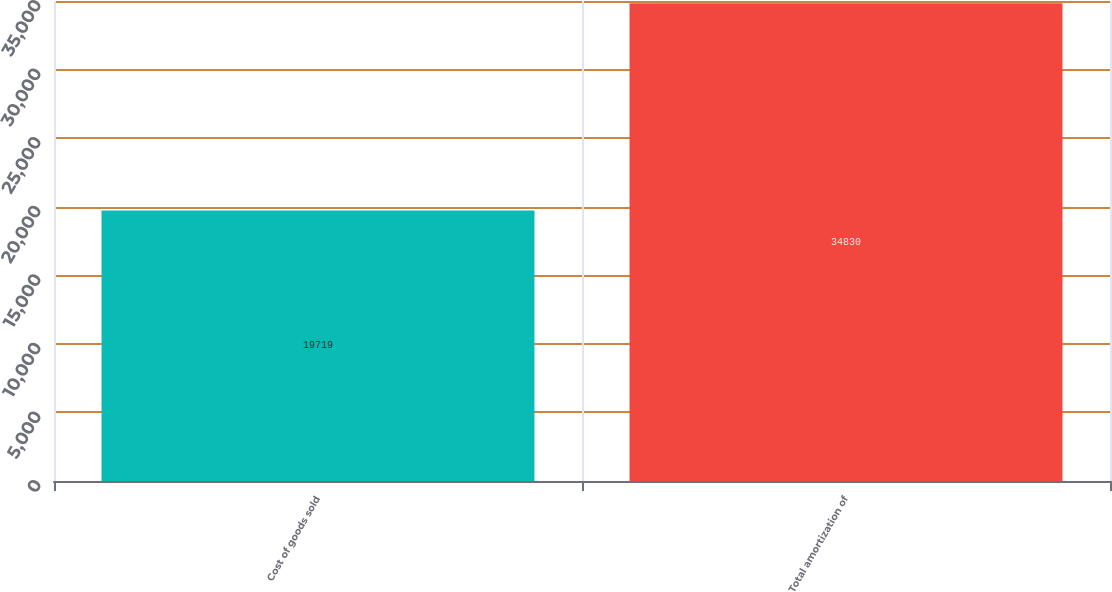<chart> <loc_0><loc_0><loc_500><loc_500><bar_chart><fcel>Cost of goods sold<fcel>Total amortization of<nl><fcel>19719<fcel>34830<nl></chart> 